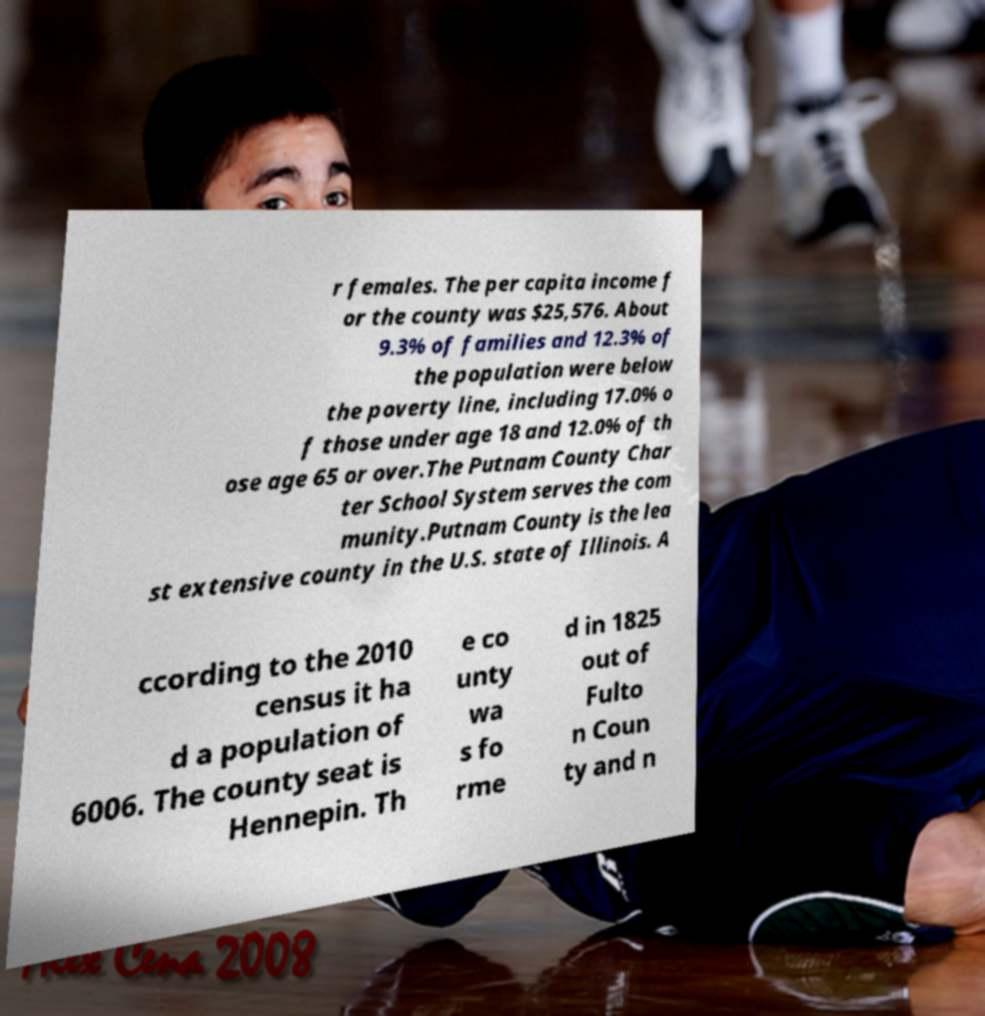Please read and relay the text visible in this image. What does it say? r females. The per capita income f or the county was $25,576. About 9.3% of families and 12.3% of the population were below the poverty line, including 17.0% o f those under age 18 and 12.0% of th ose age 65 or over.The Putnam County Char ter School System serves the com munity.Putnam County is the lea st extensive county in the U.S. state of Illinois. A ccording to the 2010 census it ha d a population of 6006. The county seat is Hennepin. Th e co unty wa s fo rme d in 1825 out of Fulto n Coun ty and n 